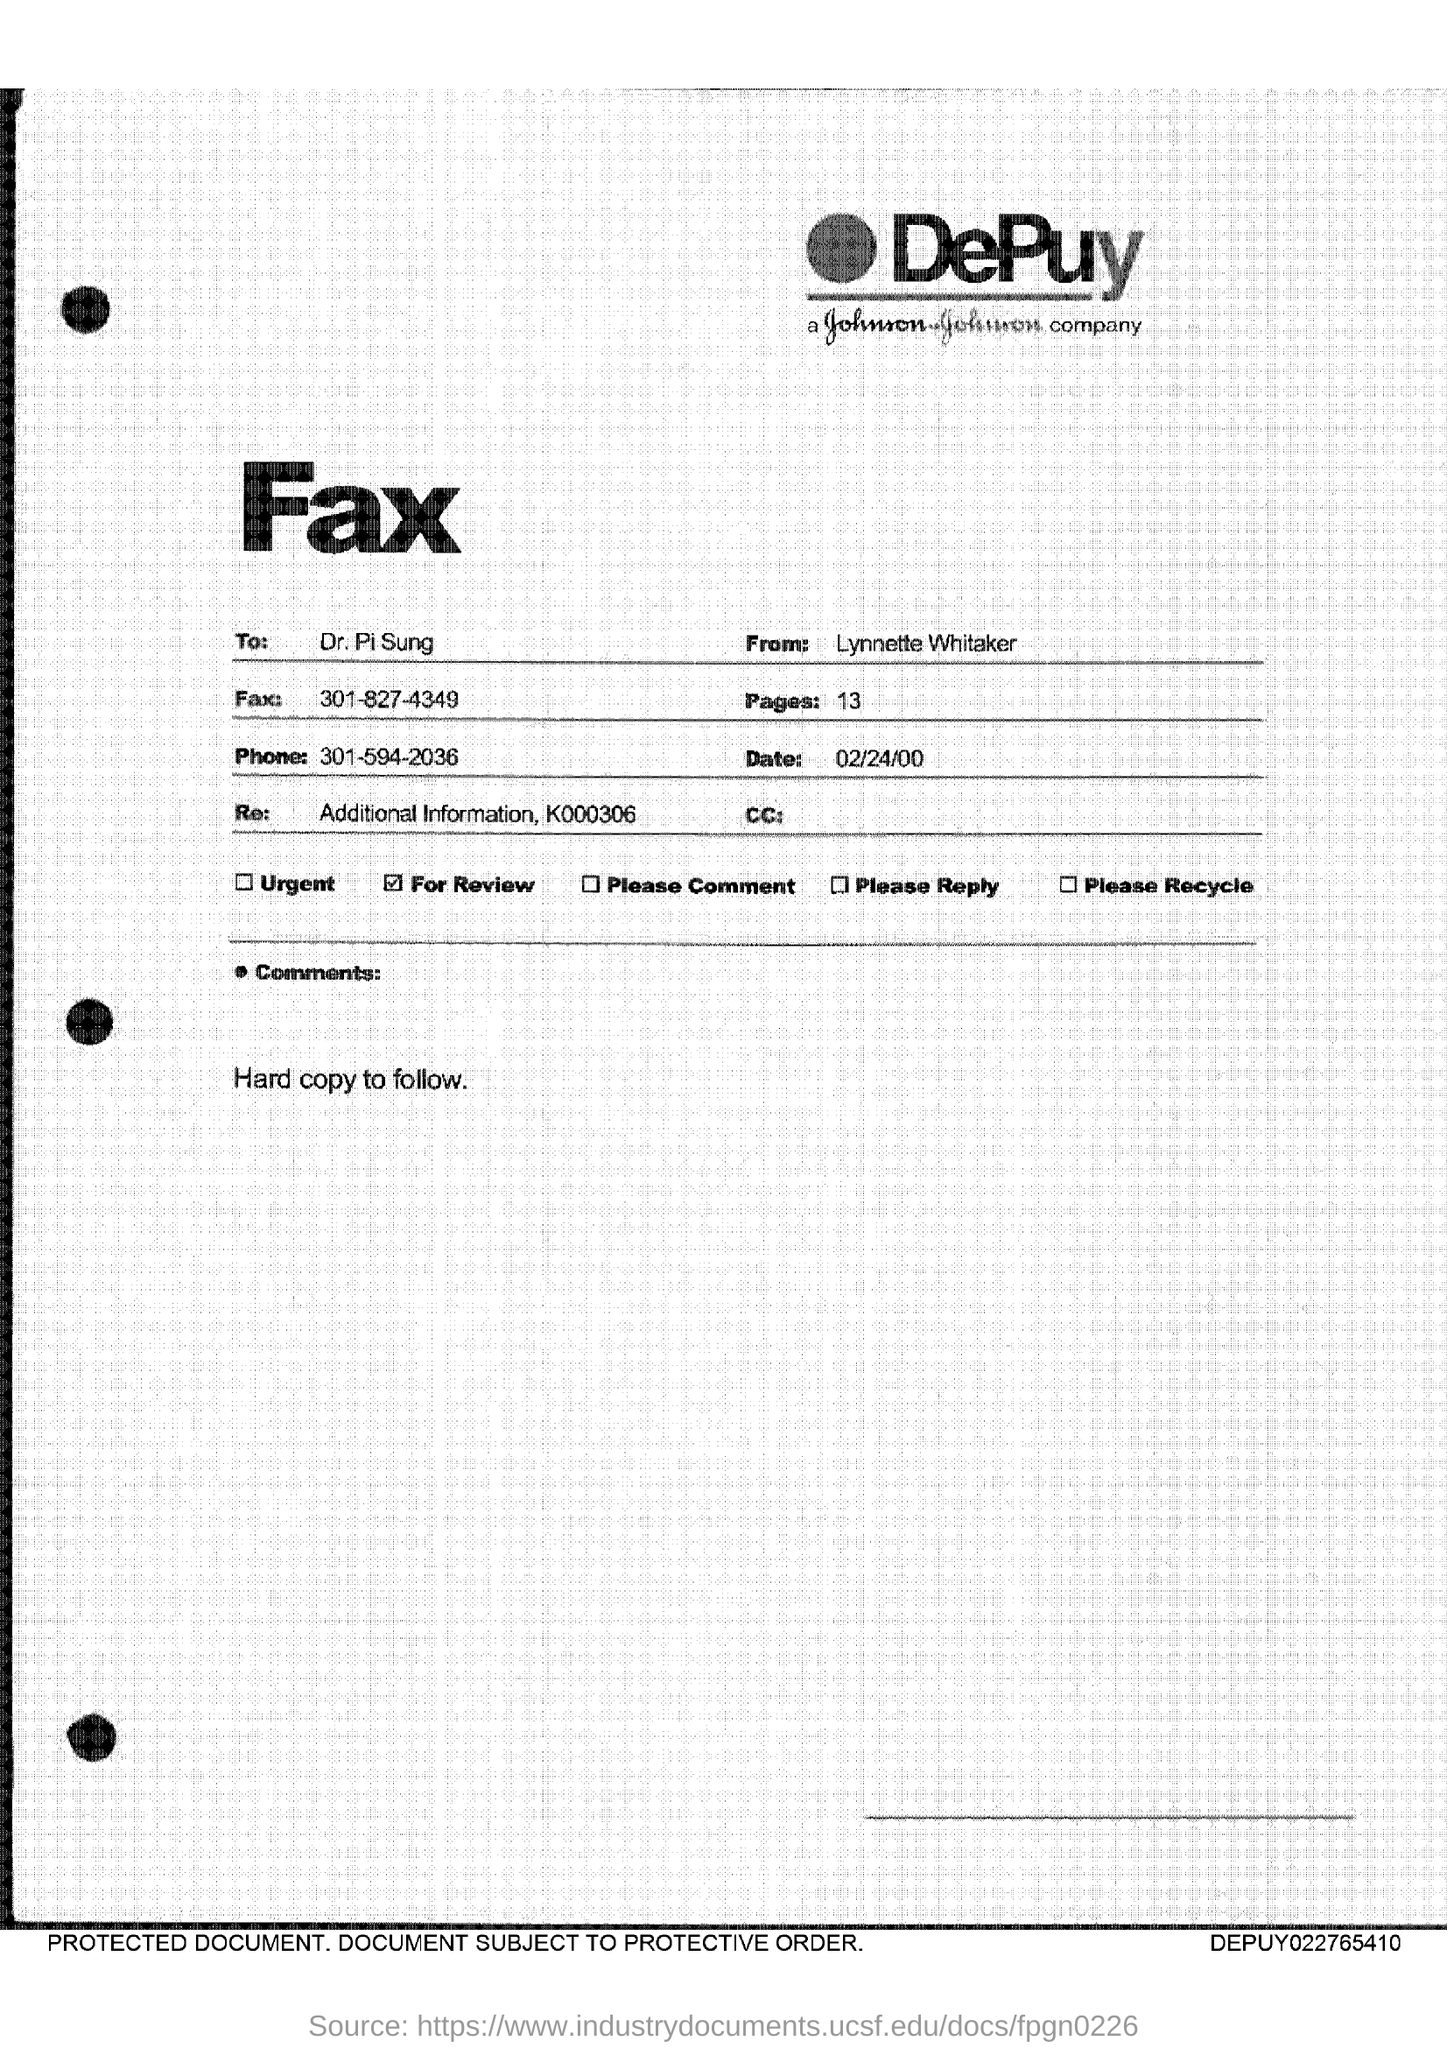Draw attention to some important aspects in this diagram. There are 13 pages in the fax. The recipient of the fax is Dr. Pi Sung. The phone number mentioned in the fax is 301-594-2036. The fax number given is 301-827-4349. The date mentioned in the fax is February 24, 2000. 